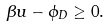Convert formula to latex. <formula><loc_0><loc_0><loc_500><loc_500>\beta u - \phi _ { D } \geq 0 .</formula> 